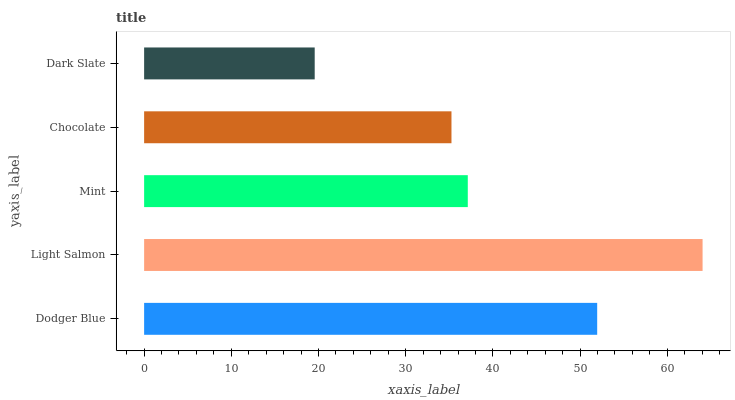Is Dark Slate the minimum?
Answer yes or no. Yes. Is Light Salmon the maximum?
Answer yes or no. Yes. Is Mint the minimum?
Answer yes or no. No. Is Mint the maximum?
Answer yes or no. No. Is Light Salmon greater than Mint?
Answer yes or no. Yes. Is Mint less than Light Salmon?
Answer yes or no. Yes. Is Mint greater than Light Salmon?
Answer yes or no. No. Is Light Salmon less than Mint?
Answer yes or no. No. Is Mint the high median?
Answer yes or no. Yes. Is Mint the low median?
Answer yes or no. Yes. Is Dark Slate the high median?
Answer yes or no. No. Is Light Salmon the low median?
Answer yes or no. No. 